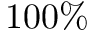Convert formula to latex. <formula><loc_0><loc_0><loc_500><loc_500>1 0 0 \%</formula> 